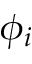<formula> <loc_0><loc_0><loc_500><loc_500>\phi _ { i }</formula> 